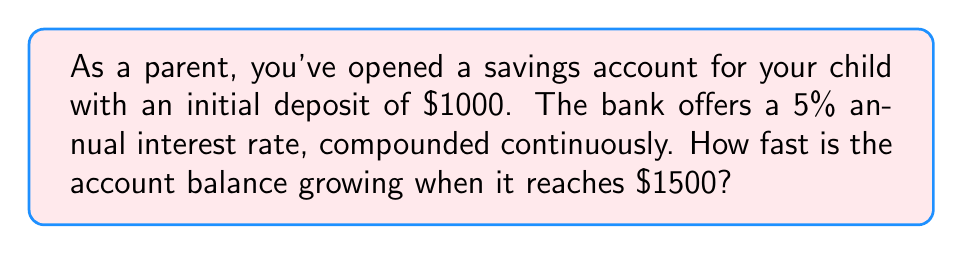Give your solution to this math problem. Let's approach this step-by-step:

1) The formula for continuous compound interest is:

   $A(t) = P e^{rt}$

   Where:
   $A(t)$ is the amount after time $t$
   $P$ is the principal (initial deposit)
   $r$ is the annual interest rate
   $t$ is the time in years

2) We're asked about the rate of growth, which is the derivative of $A(t)$ with respect to $t$:

   $\frac{dA}{dt} = P r e^{rt}$

3) We're given:
   $P = 1000$
   $r = 0.05$ (5% as a decimal)
   $A(t) = 1500$ (we want to know the rate when the balance reaches $1500)

4) To find $t$ when $A(t) = 1500$, we use the original equation:

   $1500 = 1000 e^{0.05t}$

5) Solving for $t$:

   $1.5 = e^{0.05t}$
   $\ln(1.5) = 0.05t$
   $t = \frac{\ln(1.5)}{0.05} \approx 8.13$ years

6) Now we can calculate the rate of growth:

   $\frac{dA}{dt} = 1000 \cdot 0.05 \cdot e^{0.05 \cdot 8.13}$
                 $= 50 \cdot 1.5$
                 $= 75$

Therefore, when the balance reaches $1500, it's growing at a rate of $75 per year.
Answer: $75 per year 